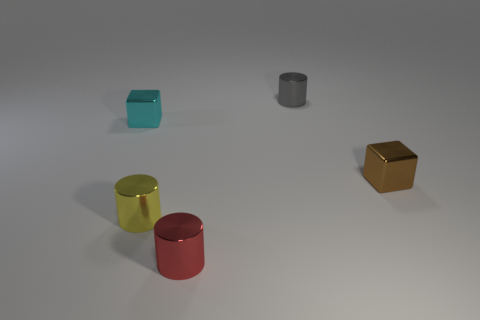Add 1 small metallic cubes. How many objects exist? 6 Subtract all red metal cylinders. How many cylinders are left? 2 Subtract 1 cubes. How many cubes are left? 1 Subtract all red cylinders. How many cylinders are left? 2 Subtract all cyan cylinders. Subtract all brown spheres. How many cylinders are left? 3 Subtract all small brown objects. Subtract all gray things. How many objects are left? 3 Add 3 shiny objects. How many shiny objects are left? 8 Add 5 metallic cylinders. How many metallic cylinders exist? 8 Subtract 0 yellow spheres. How many objects are left? 5 Subtract all cylinders. How many objects are left? 2 